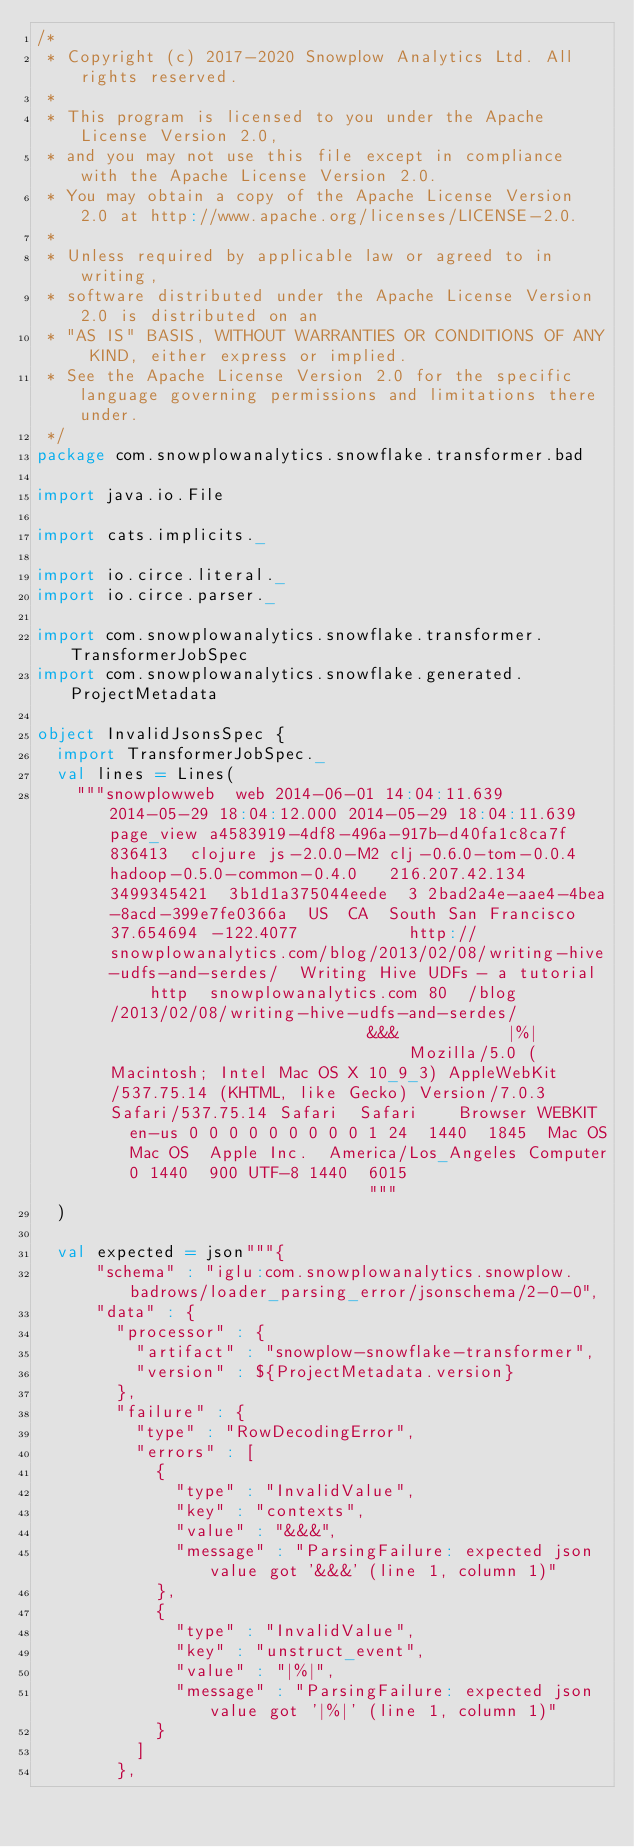Convert code to text. <code><loc_0><loc_0><loc_500><loc_500><_Scala_>/*
 * Copyright (c) 2017-2020 Snowplow Analytics Ltd. All rights reserved.
 *
 * This program is licensed to you under the Apache License Version 2.0,
 * and you may not use this file except in compliance with the Apache License Version 2.0.
 * You may obtain a copy of the Apache License Version 2.0 at http://www.apache.org/licenses/LICENSE-2.0.
 *
 * Unless required by applicable law or agreed to in writing,
 * software distributed under the Apache License Version 2.0 is distributed on an
 * "AS IS" BASIS, WITHOUT WARRANTIES OR CONDITIONS OF ANY KIND, either express or implied.
 * See the Apache License Version 2.0 for the specific language governing permissions and limitations there under.
 */
package com.snowplowanalytics.snowflake.transformer.bad

import java.io.File

import cats.implicits._

import io.circe.literal._
import io.circe.parser._

import com.snowplowanalytics.snowflake.transformer.TransformerJobSpec
import com.snowplowanalytics.snowflake.generated.ProjectMetadata

object InvalidJsonsSpec {
  import TransformerJobSpec._
  val lines = Lines(
    """snowplowweb	web	2014-06-01 14:04:11.639	2014-05-29 18:04:12.000	2014-05-29 18:04:11.639	page_view	a4583919-4df8-496a-917b-d40fa1c8ca7f	836413	clojure	js-2.0.0-M2	clj-0.6.0-tom-0.0.4	hadoop-0.5.0-common-0.4.0		216.207.42.134	3499345421	3b1d1a375044eede	3	2bad2a4e-aae4-4bea-8acd-399e7fe0366a	US	CA	South San Francisco		37.654694	-122.4077						http://snowplowanalytics.com/blog/2013/02/08/writing-hive-udfs-and-serdes/	Writing Hive UDFs - a tutorial		http	snowplowanalytics.com	80	/blog/2013/02/08/writing-hive-udfs-and-serdes/																	&&&						|%|																			Mozilla/5.0 (Macintosh; Intel Mac OS X 10_9_3) AppleWebKit/537.75.14 (KHTML, like Gecko) Version/7.0.3 Safari/537.75.14	Safari	Safari		Browser	WEBKIT	en-us	0	0	0	0	0	0	0	0	0	1	24	1440	1845	Mac OS	Mac OS	Apple Inc.	America/Los_Angeles	Computer	0	1440	900	UTF-8	1440	6015																							"""
  )

  val expected = json"""{
      "schema" : "iglu:com.snowplowanalytics.snowplow.badrows/loader_parsing_error/jsonschema/2-0-0",
      "data" : {
        "processor" : {
          "artifact" : "snowplow-snowflake-transformer",
          "version" : ${ProjectMetadata.version}
        },
        "failure" : {
          "type" : "RowDecodingError",
          "errors" : [
            {
              "type" : "InvalidValue",
              "key" : "contexts",
              "value" : "&&&",
              "message" : "ParsingFailure: expected json value got '&&&' (line 1, column 1)"
            },
            {
              "type" : "InvalidValue",
              "key" : "unstruct_event",
              "value" : "|%|",
              "message" : "ParsingFailure: expected json value got '|%|' (line 1, column 1)"
            }
          ]
        },</code> 